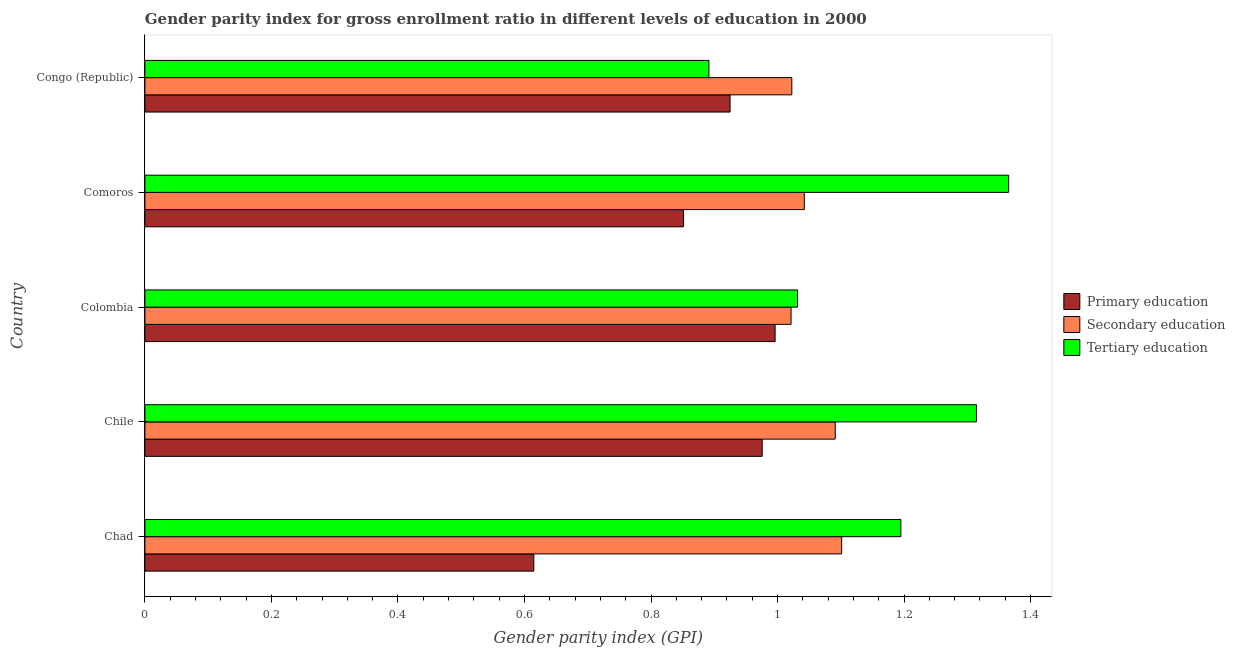How many groups of bars are there?
Make the answer very short. 5. Are the number of bars per tick equal to the number of legend labels?
Provide a short and direct response. Yes. Are the number of bars on each tick of the Y-axis equal?
Give a very brief answer. Yes. How many bars are there on the 5th tick from the top?
Ensure brevity in your answer.  3. How many bars are there on the 2nd tick from the bottom?
Your response must be concise. 3. What is the label of the 4th group of bars from the top?
Your answer should be very brief. Chile. In how many cases, is the number of bars for a given country not equal to the number of legend labels?
Your response must be concise. 0. What is the gender parity index in primary education in Chad?
Your response must be concise. 0.61. Across all countries, what is the maximum gender parity index in tertiary education?
Ensure brevity in your answer.  1.37. Across all countries, what is the minimum gender parity index in tertiary education?
Your answer should be compact. 0.89. In which country was the gender parity index in primary education maximum?
Keep it short and to the point. Colombia. In which country was the gender parity index in primary education minimum?
Provide a succinct answer. Chad. What is the total gender parity index in tertiary education in the graph?
Your response must be concise. 5.8. What is the difference between the gender parity index in primary education in Colombia and that in Comoros?
Your answer should be compact. 0.14. What is the difference between the gender parity index in primary education in Chad and the gender parity index in secondary education in Congo (Republic)?
Ensure brevity in your answer.  -0.41. What is the average gender parity index in tertiary education per country?
Offer a very short reply. 1.16. What is the difference between the gender parity index in primary education and gender parity index in tertiary education in Congo (Republic)?
Provide a succinct answer. 0.03. In how many countries, is the gender parity index in tertiary education greater than 1.12 ?
Your answer should be very brief. 3. What is the difference between the highest and the second highest gender parity index in tertiary education?
Keep it short and to the point. 0.05. What is the difference between the highest and the lowest gender parity index in tertiary education?
Your answer should be compact. 0.47. What does the 1st bar from the top in Comoros represents?
Your answer should be compact. Tertiary education. What does the 2nd bar from the bottom in Chad represents?
Provide a succinct answer. Secondary education. How many bars are there?
Keep it short and to the point. 15. Are all the bars in the graph horizontal?
Your answer should be compact. Yes. Does the graph contain grids?
Your answer should be very brief. No. What is the title of the graph?
Your response must be concise. Gender parity index for gross enrollment ratio in different levels of education in 2000. Does "Wage workers" appear as one of the legend labels in the graph?
Offer a very short reply. No. What is the label or title of the X-axis?
Offer a terse response. Gender parity index (GPI). What is the Gender parity index (GPI) in Primary education in Chad?
Keep it short and to the point. 0.61. What is the Gender parity index (GPI) of Secondary education in Chad?
Ensure brevity in your answer.  1.1. What is the Gender parity index (GPI) in Tertiary education in Chad?
Your response must be concise. 1.19. What is the Gender parity index (GPI) of Primary education in Chile?
Offer a very short reply. 0.98. What is the Gender parity index (GPI) of Secondary education in Chile?
Ensure brevity in your answer.  1.09. What is the Gender parity index (GPI) of Tertiary education in Chile?
Provide a short and direct response. 1.31. What is the Gender parity index (GPI) in Primary education in Colombia?
Make the answer very short. 1. What is the Gender parity index (GPI) of Secondary education in Colombia?
Keep it short and to the point. 1.02. What is the Gender parity index (GPI) in Tertiary education in Colombia?
Offer a terse response. 1.03. What is the Gender parity index (GPI) of Primary education in Comoros?
Your answer should be very brief. 0.85. What is the Gender parity index (GPI) of Secondary education in Comoros?
Give a very brief answer. 1.04. What is the Gender parity index (GPI) in Tertiary education in Comoros?
Keep it short and to the point. 1.37. What is the Gender parity index (GPI) of Primary education in Congo (Republic)?
Make the answer very short. 0.92. What is the Gender parity index (GPI) in Secondary education in Congo (Republic)?
Offer a terse response. 1.02. What is the Gender parity index (GPI) of Tertiary education in Congo (Republic)?
Ensure brevity in your answer.  0.89. Across all countries, what is the maximum Gender parity index (GPI) of Primary education?
Offer a terse response. 1. Across all countries, what is the maximum Gender parity index (GPI) of Secondary education?
Ensure brevity in your answer.  1.1. Across all countries, what is the maximum Gender parity index (GPI) in Tertiary education?
Keep it short and to the point. 1.37. Across all countries, what is the minimum Gender parity index (GPI) of Primary education?
Give a very brief answer. 0.61. Across all countries, what is the minimum Gender parity index (GPI) in Secondary education?
Your answer should be very brief. 1.02. Across all countries, what is the minimum Gender parity index (GPI) in Tertiary education?
Your response must be concise. 0.89. What is the total Gender parity index (GPI) in Primary education in the graph?
Provide a short and direct response. 4.36. What is the total Gender parity index (GPI) of Secondary education in the graph?
Ensure brevity in your answer.  5.28. What is the total Gender parity index (GPI) of Tertiary education in the graph?
Provide a short and direct response. 5.8. What is the difference between the Gender parity index (GPI) in Primary education in Chad and that in Chile?
Make the answer very short. -0.36. What is the difference between the Gender parity index (GPI) in Secondary education in Chad and that in Chile?
Your answer should be compact. 0.01. What is the difference between the Gender parity index (GPI) of Tertiary education in Chad and that in Chile?
Provide a succinct answer. -0.12. What is the difference between the Gender parity index (GPI) of Primary education in Chad and that in Colombia?
Your answer should be very brief. -0.38. What is the difference between the Gender parity index (GPI) of Secondary education in Chad and that in Colombia?
Provide a short and direct response. 0.08. What is the difference between the Gender parity index (GPI) in Tertiary education in Chad and that in Colombia?
Make the answer very short. 0.16. What is the difference between the Gender parity index (GPI) of Primary education in Chad and that in Comoros?
Keep it short and to the point. -0.24. What is the difference between the Gender parity index (GPI) of Secondary education in Chad and that in Comoros?
Make the answer very short. 0.06. What is the difference between the Gender parity index (GPI) of Tertiary education in Chad and that in Comoros?
Give a very brief answer. -0.17. What is the difference between the Gender parity index (GPI) of Primary education in Chad and that in Congo (Republic)?
Provide a succinct answer. -0.31. What is the difference between the Gender parity index (GPI) of Secondary education in Chad and that in Congo (Republic)?
Offer a terse response. 0.08. What is the difference between the Gender parity index (GPI) of Tertiary education in Chad and that in Congo (Republic)?
Provide a short and direct response. 0.3. What is the difference between the Gender parity index (GPI) of Primary education in Chile and that in Colombia?
Give a very brief answer. -0.02. What is the difference between the Gender parity index (GPI) in Secondary education in Chile and that in Colombia?
Offer a terse response. 0.07. What is the difference between the Gender parity index (GPI) in Tertiary education in Chile and that in Colombia?
Your response must be concise. 0.28. What is the difference between the Gender parity index (GPI) of Primary education in Chile and that in Comoros?
Ensure brevity in your answer.  0.12. What is the difference between the Gender parity index (GPI) of Secondary education in Chile and that in Comoros?
Provide a succinct answer. 0.05. What is the difference between the Gender parity index (GPI) of Tertiary education in Chile and that in Comoros?
Offer a very short reply. -0.05. What is the difference between the Gender parity index (GPI) in Primary education in Chile and that in Congo (Republic)?
Provide a succinct answer. 0.05. What is the difference between the Gender parity index (GPI) in Secondary education in Chile and that in Congo (Republic)?
Make the answer very short. 0.07. What is the difference between the Gender parity index (GPI) of Tertiary education in Chile and that in Congo (Republic)?
Keep it short and to the point. 0.42. What is the difference between the Gender parity index (GPI) of Primary education in Colombia and that in Comoros?
Your answer should be compact. 0.14. What is the difference between the Gender parity index (GPI) of Secondary education in Colombia and that in Comoros?
Provide a succinct answer. -0.02. What is the difference between the Gender parity index (GPI) of Tertiary education in Colombia and that in Comoros?
Provide a succinct answer. -0.33. What is the difference between the Gender parity index (GPI) of Primary education in Colombia and that in Congo (Republic)?
Provide a short and direct response. 0.07. What is the difference between the Gender parity index (GPI) of Secondary education in Colombia and that in Congo (Republic)?
Offer a terse response. -0. What is the difference between the Gender parity index (GPI) in Tertiary education in Colombia and that in Congo (Republic)?
Make the answer very short. 0.14. What is the difference between the Gender parity index (GPI) in Primary education in Comoros and that in Congo (Republic)?
Offer a very short reply. -0.07. What is the difference between the Gender parity index (GPI) of Secondary education in Comoros and that in Congo (Republic)?
Provide a short and direct response. 0.02. What is the difference between the Gender parity index (GPI) in Tertiary education in Comoros and that in Congo (Republic)?
Give a very brief answer. 0.47. What is the difference between the Gender parity index (GPI) in Primary education in Chad and the Gender parity index (GPI) in Secondary education in Chile?
Offer a very short reply. -0.48. What is the difference between the Gender parity index (GPI) of Primary education in Chad and the Gender parity index (GPI) of Tertiary education in Chile?
Your response must be concise. -0.7. What is the difference between the Gender parity index (GPI) in Secondary education in Chad and the Gender parity index (GPI) in Tertiary education in Chile?
Keep it short and to the point. -0.21. What is the difference between the Gender parity index (GPI) of Primary education in Chad and the Gender parity index (GPI) of Secondary education in Colombia?
Ensure brevity in your answer.  -0.41. What is the difference between the Gender parity index (GPI) in Primary education in Chad and the Gender parity index (GPI) in Tertiary education in Colombia?
Provide a short and direct response. -0.42. What is the difference between the Gender parity index (GPI) in Secondary education in Chad and the Gender parity index (GPI) in Tertiary education in Colombia?
Give a very brief answer. 0.07. What is the difference between the Gender parity index (GPI) of Primary education in Chad and the Gender parity index (GPI) of Secondary education in Comoros?
Keep it short and to the point. -0.43. What is the difference between the Gender parity index (GPI) in Primary education in Chad and the Gender parity index (GPI) in Tertiary education in Comoros?
Provide a short and direct response. -0.75. What is the difference between the Gender parity index (GPI) in Secondary education in Chad and the Gender parity index (GPI) in Tertiary education in Comoros?
Offer a terse response. -0.26. What is the difference between the Gender parity index (GPI) of Primary education in Chad and the Gender parity index (GPI) of Secondary education in Congo (Republic)?
Your response must be concise. -0.41. What is the difference between the Gender parity index (GPI) of Primary education in Chad and the Gender parity index (GPI) of Tertiary education in Congo (Republic)?
Your answer should be very brief. -0.28. What is the difference between the Gender parity index (GPI) of Secondary education in Chad and the Gender parity index (GPI) of Tertiary education in Congo (Republic)?
Your answer should be very brief. 0.21. What is the difference between the Gender parity index (GPI) in Primary education in Chile and the Gender parity index (GPI) in Secondary education in Colombia?
Make the answer very short. -0.05. What is the difference between the Gender parity index (GPI) in Primary education in Chile and the Gender parity index (GPI) in Tertiary education in Colombia?
Make the answer very short. -0.06. What is the difference between the Gender parity index (GPI) of Secondary education in Chile and the Gender parity index (GPI) of Tertiary education in Colombia?
Make the answer very short. 0.06. What is the difference between the Gender parity index (GPI) in Primary education in Chile and the Gender parity index (GPI) in Secondary education in Comoros?
Ensure brevity in your answer.  -0.07. What is the difference between the Gender parity index (GPI) of Primary education in Chile and the Gender parity index (GPI) of Tertiary education in Comoros?
Offer a terse response. -0.39. What is the difference between the Gender parity index (GPI) of Secondary education in Chile and the Gender parity index (GPI) of Tertiary education in Comoros?
Provide a succinct answer. -0.27. What is the difference between the Gender parity index (GPI) of Primary education in Chile and the Gender parity index (GPI) of Secondary education in Congo (Republic)?
Your answer should be very brief. -0.05. What is the difference between the Gender parity index (GPI) in Primary education in Chile and the Gender parity index (GPI) in Tertiary education in Congo (Republic)?
Provide a short and direct response. 0.08. What is the difference between the Gender parity index (GPI) of Secondary education in Chile and the Gender parity index (GPI) of Tertiary education in Congo (Republic)?
Ensure brevity in your answer.  0.2. What is the difference between the Gender parity index (GPI) of Primary education in Colombia and the Gender parity index (GPI) of Secondary education in Comoros?
Offer a very short reply. -0.05. What is the difference between the Gender parity index (GPI) in Primary education in Colombia and the Gender parity index (GPI) in Tertiary education in Comoros?
Ensure brevity in your answer.  -0.37. What is the difference between the Gender parity index (GPI) of Secondary education in Colombia and the Gender parity index (GPI) of Tertiary education in Comoros?
Give a very brief answer. -0.34. What is the difference between the Gender parity index (GPI) in Primary education in Colombia and the Gender parity index (GPI) in Secondary education in Congo (Republic)?
Provide a short and direct response. -0.03. What is the difference between the Gender parity index (GPI) in Primary education in Colombia and the Gender parity index (GPI) in Tertiary education in Congo (Republic)?
Offer a very short reply. 0.1. What is the difference between the Gender parity index (GPI) of Secondary education in Colombia and the Gender parity index (GPI) of Tertiary education in Congo (Republic)?
Your answer should be very brief. 0.13. What is the difference between the Gender parity index (GPI) in Primary education in Comoros and the Gender parity index (GPI) in Secondary education in Congo (Republic)?
Your answer should be compact. -0.17. What is the difference between the Gender parity index (GPI) of Primary education in Comoros and the Gender parity index (GPI) of Tertiary education in Congo (Republic)?
Offer a very short reply. -0.04. What is the difference between the Gender parity index (GPI) in Secondary education in Comoros and the Gender parity index (GPI) in Tertiary education in Congo (Republic)?
Give a very brief answer. 0.15. What is the average Gender parity index (GPI) in Primary education per country?
Provide a short and direct response. 0.87. What is the average Gender parity index (GPI) of Secondary education per country?
Your response must be concise. 1.06. What is the average Gender parity index (GPI) in Tertiary education per country?
Your answer should be compact. 1.16. What is the difference between the Gender parity index (GPI) in Primary education and Gender parity index (GPI) in Secondary education in Chad?
Make the answer very short. -0.49. What is the difference between the Gender parity index (GPI) of Primary education and Gender parity index (GPI) of Tertiary education in Chad?
Your response must be concise. -0.58. What is the difference between the Gender parity index (GPI) of Secondary education and Gender parity index (GPI) of Tertiary education in Chad?
Make the answer very short. -0.09. What is the difference between the Gender parity index (GPI) of Primary education and Gender parity index (GPI) of Secondary education in Chile?
Provide a succinct answer. -0.12. What is the difference between the Gender parity index (GPI) of Primary education and Gender parity index (GPI) of Tertiary education in Chile?
Provide a succinct answer. -0.34. What is the difference between the Gender parity index (GPI) of Secondary education and Gender parity index (GPI) of Tertiary education in Chile?
Provide a succinct answer. -0.22. What is the difference between the Gender parity index (GPI) in Primary education and Gender parity index (GPI) in Secondary education in Colombia?
Offer a terse response. -0.03. What is the difference between the Gender parity index (GPI) in Primary education and Gender parity index (GPI) in Tertiary education in Colombia?
Your response must be concise. -0.04. What is the difference between the Gender parity index (GPI) of Secondary education and Gender parity index (GPI) of Tertiary education in Colombia?
Make the answer very short. -0.01. What is the difference between the Gender parity index (GPI) of Primary education and Gender parity index (GPI) of Secondary education in Comoros?
Your response must be concise. -0.19. What is the difference between the Gender parity index (GPI) of Primary education and Gender parity index (GPI) of Tertiary education in Comoros?
Your answer should be compact. -0.51. What is the difference between the Gender parity index (GPI) of Secondary education and Gender parity index (GPI) of Tertiary education in Comoros?
Provide a succinct answer. -0.32. What is the difference between the Gender parity index (GPI) of Primary education and Gender parity index (GPI) of Secondary education in Congo (Republic)?
Offer a very short reply. -0.1. What is the difference between the Gender parity index (GPI) in Primary education and Gender parity index (GPI) in Tertiary education in Congo (Republic)?
Keep it short and to the point. 0.03. What is the difference between the Gender parity index (GPI) in Secondary education and Gender parity index (GPI) in Tertiary education in Congo (Republic)?
Your answer should be very brief. 0.13. What is the ratio of the Gender parity index (GPI) in Primary education in Chad to that in Chile?
Ensure brevity in your answer.  0.63. What is the ratio of the Gender parity index (GPI) in Secondary education in Chad to that in Chile?
Offer a terse response. 1.01. What is the ratio of the Gender parity index (GPI) in Tertiary education in Chad to that in Chile?
Offer a terse response. 0.91. What is the ratio of the Gender parity index (GPI) in Primary education in Chad to that in Colombia?
Your answer should be compact. 0.62. What is the ratio of the Gender parity index (GPI) in Secondary education in Chad to that in Colombia?
Offer a very short reply. 1.08. What is the ratio of the Gender parity index (GPI) in Tertiary education in Chad to that in Colombia?
Keep it short and to the point. 1.16. What is the ratio of the Gender parity index (GPI) of Primary education in Chad to that in Comoros?
Provide a succinct answer. 0.72. What is the ratio of the Gender parity index (GPI) in Secondary education in Chad to that in Comoros?
Make the answer very short. 1.06. What is the ratio of the Gender parity index (GPI) in Tertiary education in Chad to that in Comoros?
Your answer should be very brief. 0.88. What is the ratio of the Gender parity index (GPI) of Primary education in Chad to that in Congo (Republic)?
Provide a short and direct response. 0.66. What is the ratio of the Gender parity index (GPI) of Secondary education in Chad to that in Congo (Republic)?
Keep it short and to the point. 1.08. What is the ratio of the Gender parity index (GPI) of Tertiary education in Chad to that in Congo (Republic)?
Your answer should be compact. 1.34. What is the ratio of the Gender parity index (GPI) in Primary education in Chile to that in Colombia?
Your answer should be very brief. 0.98. What is the ratio of the Gender parity index (GPI) in Secondary education in Chile to that in Colombia?
Your answer should be very brief. 1.07. What is the ratio of the Gender parity index (GPI) in Tertiary education in Chile to that in Colombia?
Keep it short and to the point. 1.27. What is the ratio of the Gender parity index (GPI) of Primary education in Chile to that in Comoros?
Offer a terse response. 1.15. What is the ratio of the Gender parity index (GPI) of Secondary education in Chile to that in Comoros?
Provide a short and direct response. 1.05. What is the ratio of the Gender parity index (GPI) in Tertiary education in Chile to that in Comoros?
Your response must be concise. 0.96. What is the ratio of the Gender parity index (GPI) of Primary education in Chile to that in Congo (Republic)?
Make the answer very short. 1.05. What is the ratio of the Gender parity index (GPI) in Secondary education in Chile to that in Congo (Republic)?
Ensure brevity in your answer.  1.07. What is the ratio of the Gender parity index (GPI) of Tertiary education in Chile to that in Congo (Republic)?
Make the answer very short. 1.47. What is the ratio of the Gender parity index (GPI) in Primary education in Colombia to that in Comoros?
Keep it short and to the point. 1.17. What is the ratio of the Gender parity index (GPI) of Secondary education in Colombia to that in Comoros?
Provide a short and direct response. 0.98. What is the ratio of the Gender parity index (GPI) in Tertiary education in Colombia to that in Comoros?
Provide a succinct answer. 0.76. What is the ratio of the Gender parity index (GPI) of Primary education in Colombia to that in Congo (Republic)?
Provide a short and direct response. 1.08. What is the ratio of the Gender parity index (GPI) in Secondary education in Colombia to that in Congo (Republic)?
Keep it short and to the point. 1. What is the ratio of the Gender parity index (GPI) of Tertiary education in Colombia to that in Congo (Republic)?
Offer a very short reply. 1.16. What is the ratio of the Gender parity index (GPI) in Primary education in Comoros to that in Congo (Republic)?
Your answer should be very brief. 0.92. What is the ratio of the Gender parity index (GPI) in Secondary education in Comoros to that in Congo (Republic)?
Your answer should be compact. 1.02. What is the ratio of the Gender parity index (GPI) of Tertiary education in Comoros to that in Congo (Republic)?
Your answer should be very brief. 1.53. What is the difference between the highest and the second highest Gender parity index (GPI) of Primary education?
Provide a short and direct response. 0.02. What is the difference between the highest and the second highest Gender parity index (GPI) in Secondary education?
Your answer should be compact. 0.01. What is the difference between the highest and the second highest Gender parity index (GPI) of Tertiary education?
Make the answer very short. 0.05. What is the difference between the highest and the lowest Gender parity index (GPI) in Primary education?
Your response must be concise. 0.38. What is the difference between the highest and the lowest Gender parity index (GPI) in Secondary education?
Give a very brief answer. 0.08. What is the difference between the highest and the lowest Gender parity index (GPI) of Tertiary education?
Make the answer very short. 0.47. 